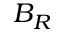Convert formula to latex. <formula><loc_0><loc_0><loc_500><loc_500>B _ { R }</formula> 